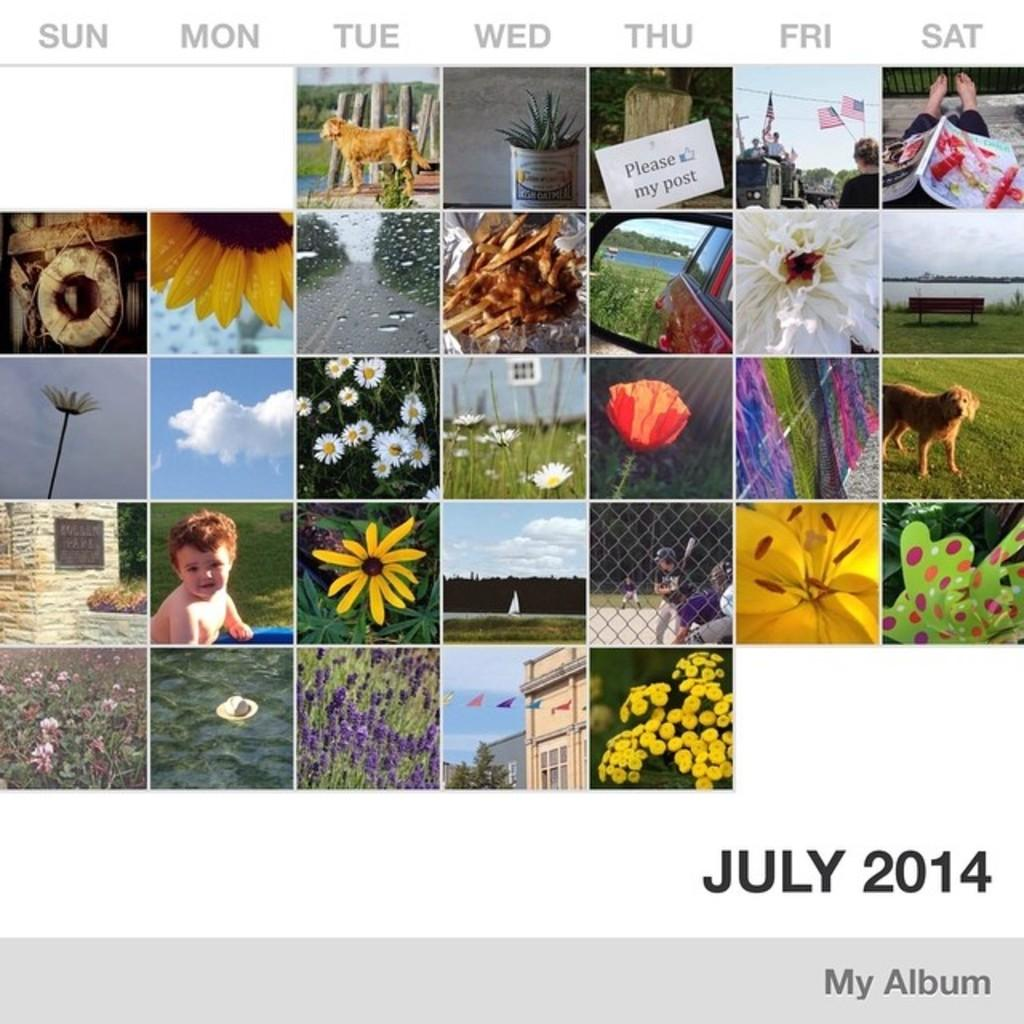What is the main subject of the image? The main subject of the image is a photo collage. Can you describe the photo collage in more detail? Yes, there is text on the photo collage. What type of company is depicted in the photo collage? There is no company depicted in the photo collage; it is a collection of photos and text. What kind of pancake is being served in the photo collage? There is no pancake present in the photo collage; it consists of photos and text. 